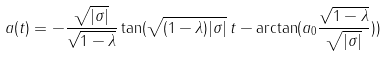<formula> <loc_0><loc_0><loc_500><loc_500>a ( t ) = - \frac { \sqrt { | \sigma | } } { \sqrt { 1 - \lambda } } \tan ( \sqrt { ( 1 - \lambda ) | \sigma | } \, t - \arctan ( a _ { 0 } \frac { \sqrt { 1 - \lambda } } { \sqrt { | \sigma | } } ) )</formula> 